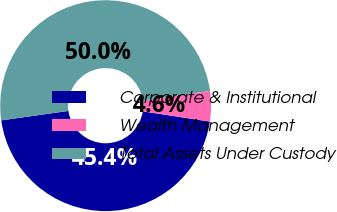Convert chart to OTSL. <chart><loc_0><loc_0><loc_500><loc_500><pie_chart><fcel>Corporate & Institutional<fcel>Wealth Management<fcel>Total Assets Under Custody<nl><fcel>45.36%<fcel>4.64%<fcel>50.0%<nl></chart> 